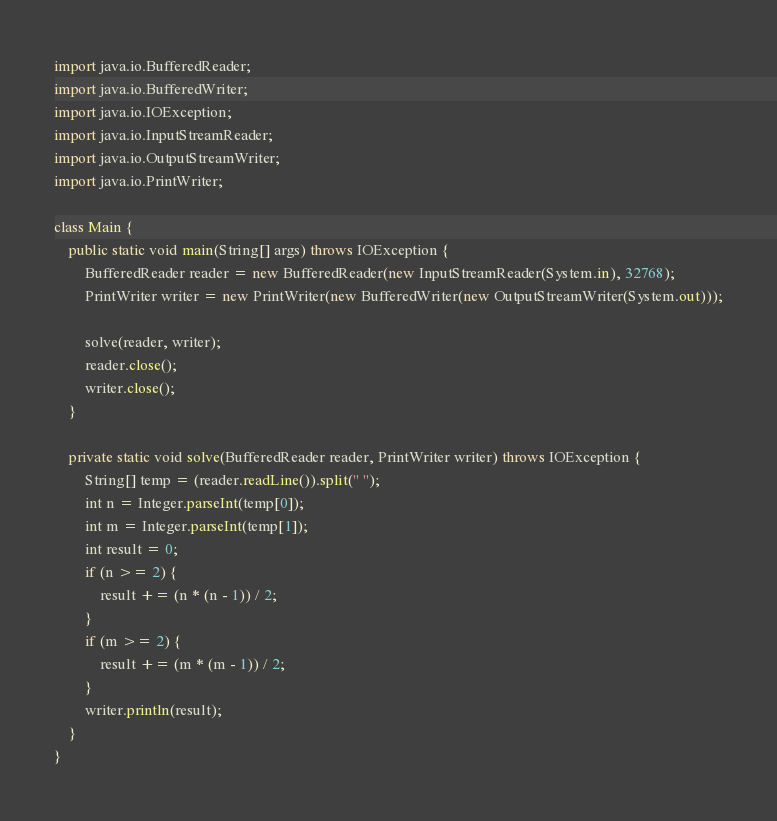Convert code to text. <code><loc_0><loc_0><loc_500><loc_500><_Java_>import java.io.BufferedReader;
import java.io.BufferedWriter;
import java.io.IOException;
import java.io.InputStreamReader;
import java.io.OutputStreamWriter;
import java.io.PrintWriter;

class Main {
	public static void main(String[] args) throws IOException {
		BufferedReader reader = new BufferedReader(new InputStreamReader(System.in), 32768);
		PrintWriter writer = new PrintWriter(new BufferedWriter(new OutputStreamWriter(System.out)));

		solve(reader, writer);
		reader.close();
		writer.close();
	}

	private static void solve(BufferedReader reader, PrintWriter writer) throws IOException {
		String[] temp = (reader.readLine()).split(" ");
		int n = Integer.parseInt(temp[0]);
		int m = Integer.parseInt(temp[1]);
		int result = 0;
		if (n >= 2) {
			result += (n * (n - 1)) / 2;
		}
		if (m >= 2) {
			result += (m * (m - 1)) / 2;
		}
		writer.println(result);
	}
}
</code> 